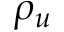Convert formula to latex. <formula><loc_0><loc_0><loc_500><loc_500>\rho _ { u }</formula> 